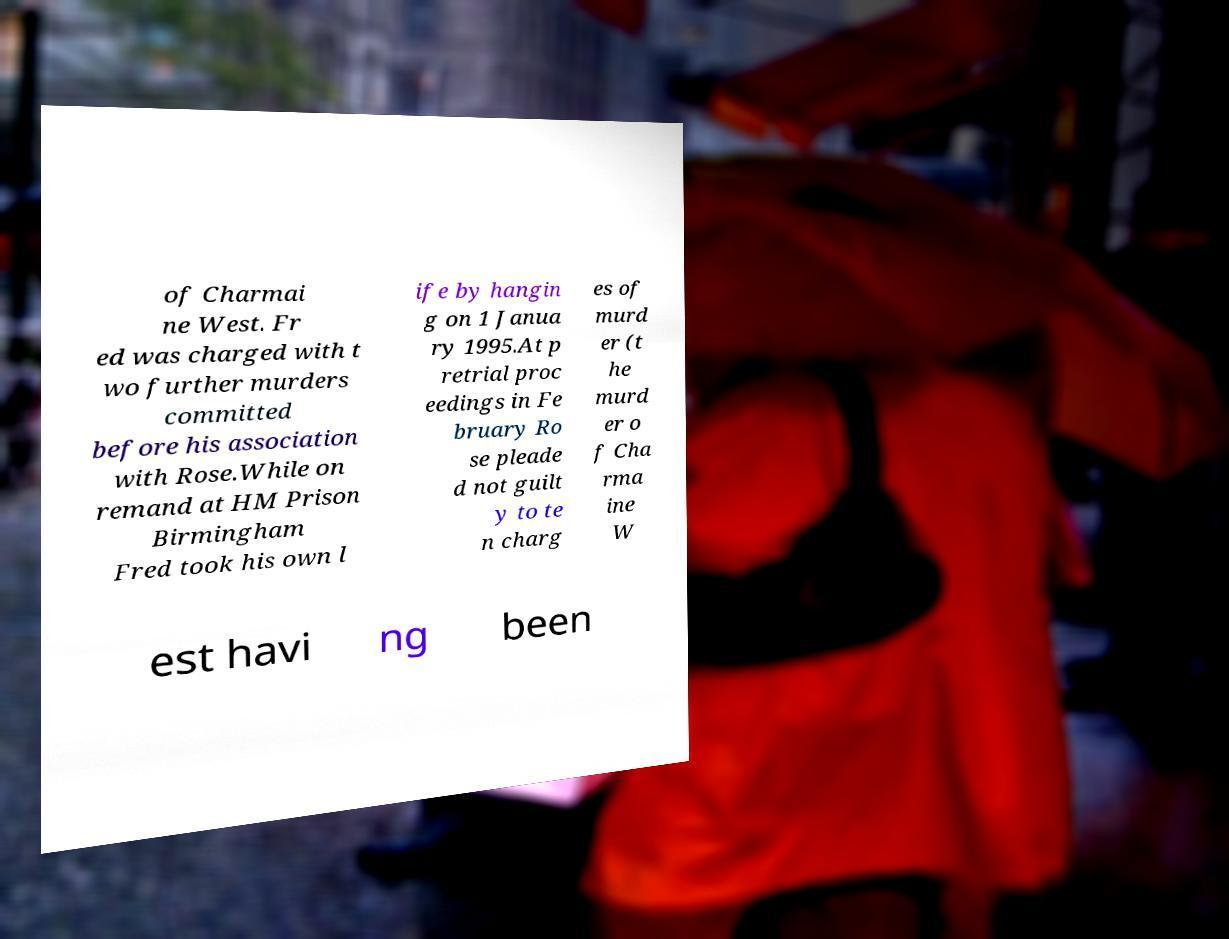Can you accurately transcribe the text from the provided image for me? of Charmai ne West. Fr ed was charged with t wo further murders committed before his association with Rose.While on remand at HM Prison Birmingham Fred took his own l ife by hangin g on 1 Janua ry 1995.At p retrial proc eedings in Fe bruary Ro se pleade d not guilt y to te n charg es of murd er (t he murd er o f Cha rma ine W est havi ng been 